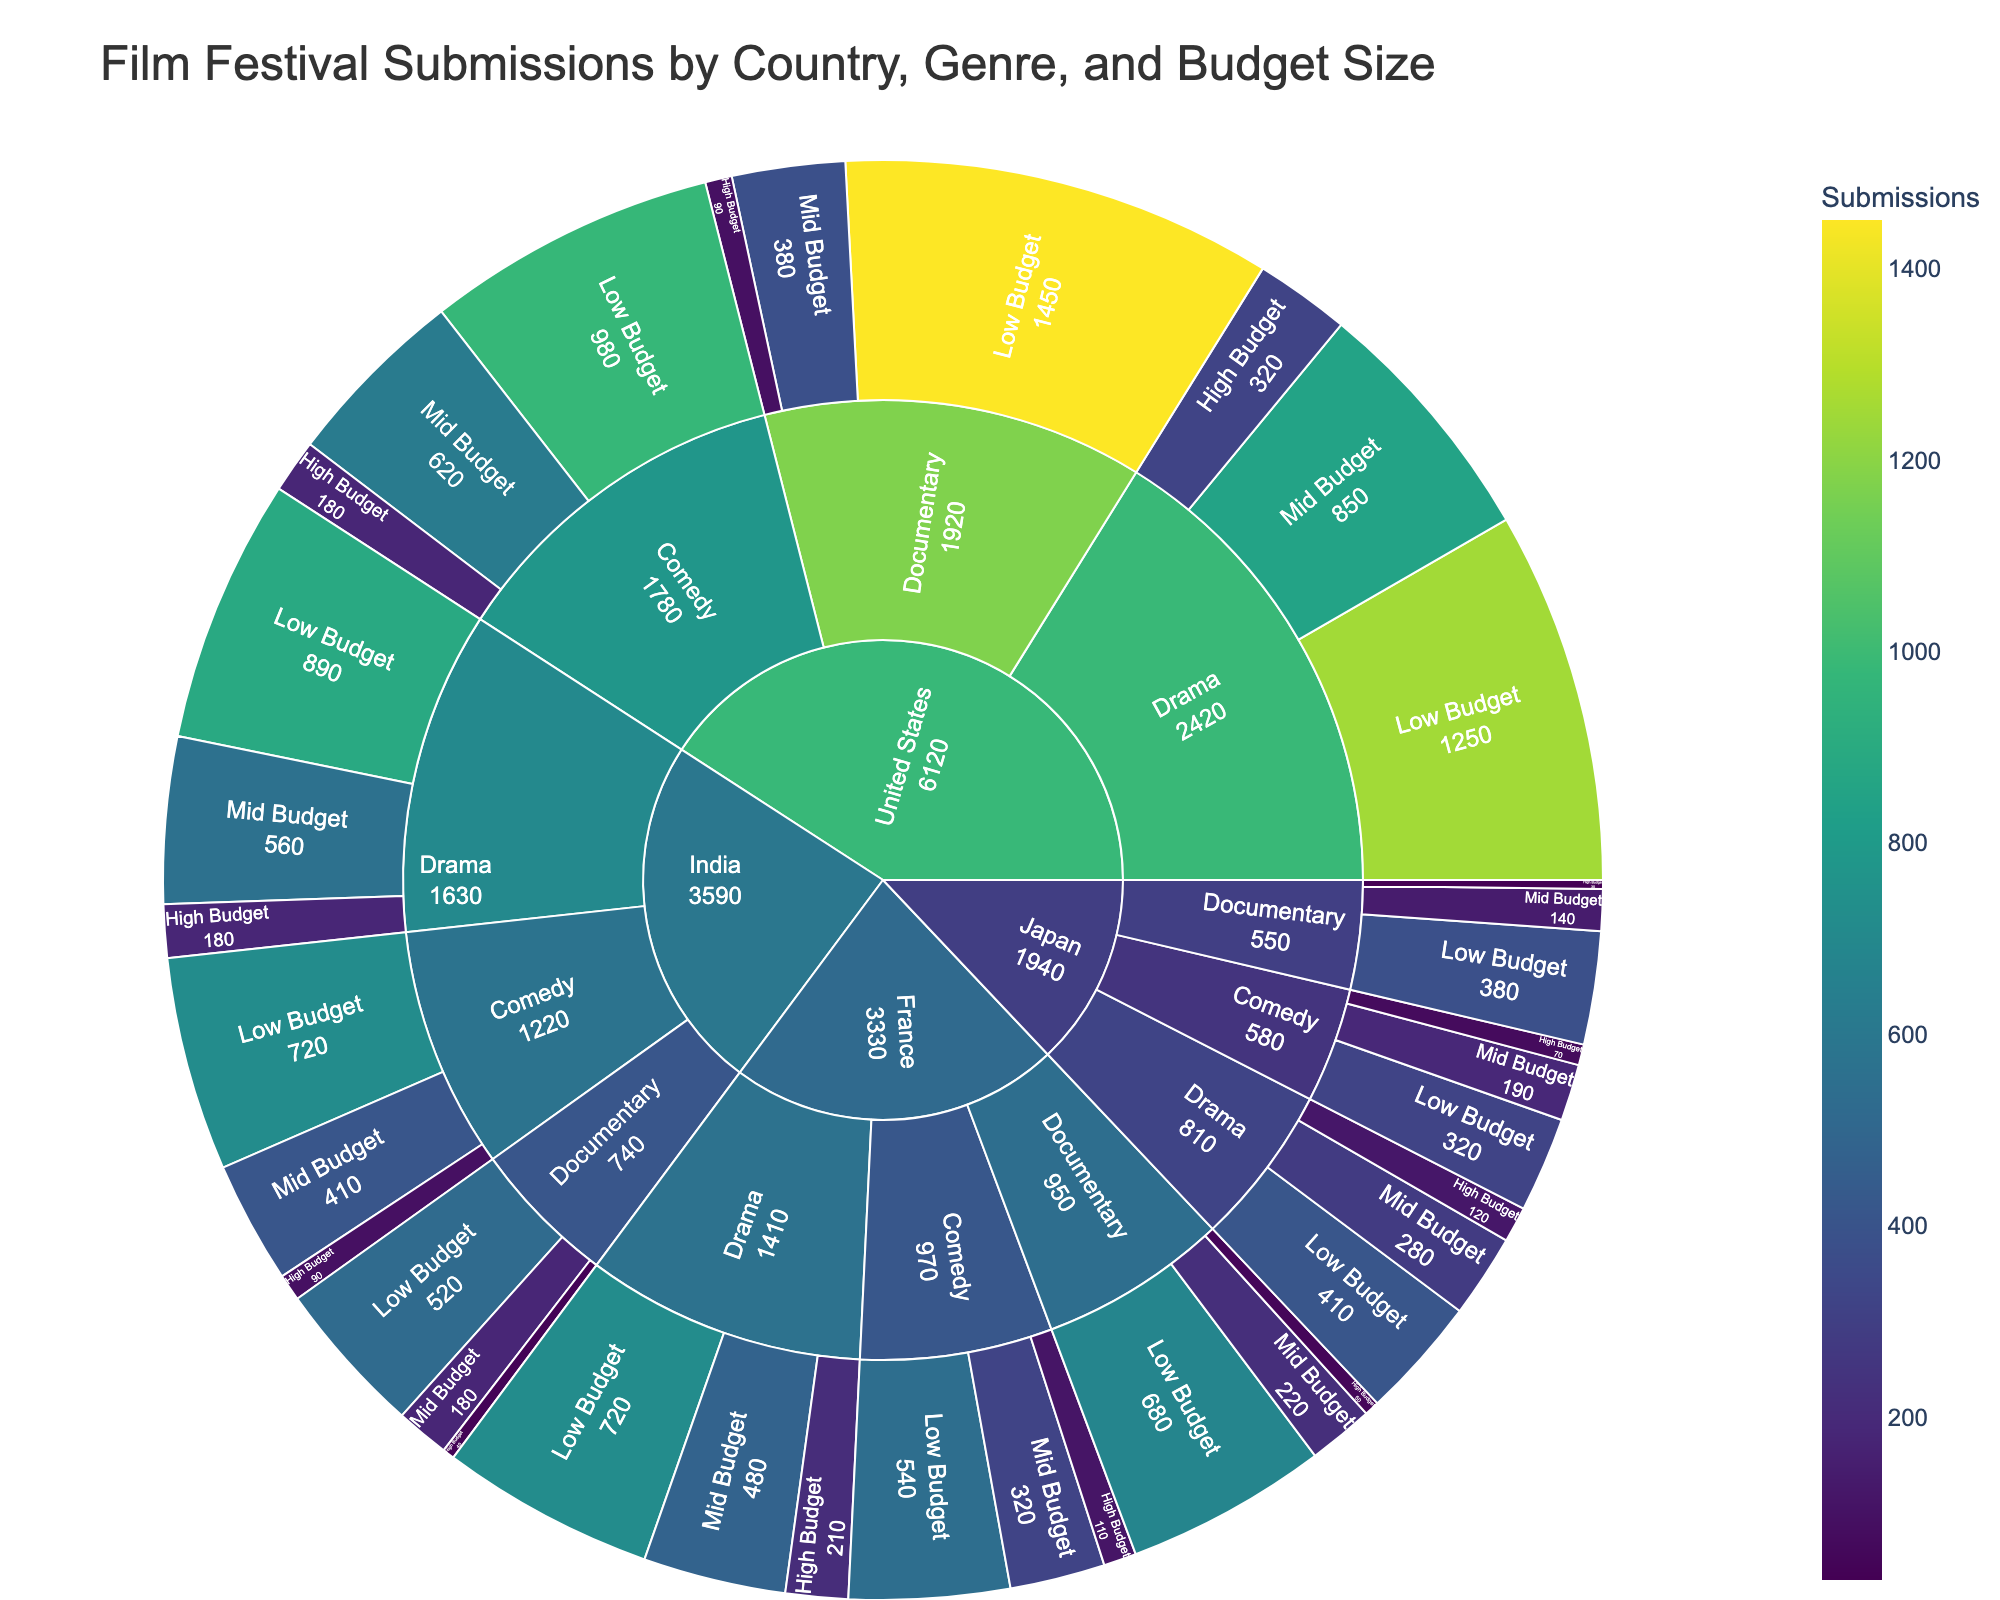What is the total number of film festival submissions from the United States? Sum the submissions for all genres and budget sizes within the United States section of the Sunburst plot: Drama (1250 + 850 + 320), Comedy (980 + 620 + 180), Documentary (1450 + 380 + 90). Calculate the total (1250 + 850 + 320 + 980 + 620 + 180 + 1450 + 380 + 90)
Answer: 6120 Which country has the highest number of low-budget documentary submissions? Identify the "Documentary" genre under "Low Budget" in each country's section and compare submission numbers: United States (1450), France (680), Japan (380), India (520). The United States has the highest
Answer: United States What genre has the least high-budget submissions in France? Look at the "High Budget" submissions under each genre in the France section: Drama (210), Comedy (110), Documentary (50). The Documentary genre has the least
Answer: Documentary Among the genres within Japan, which one has the highest mid-budget submissions? Compare the mid-budget submissions across genres within the Japan section: Drama (280), Comedy (190), Documentary (140). Drama has the highest
Answer: Drama How do the mid-budget drama submissions from India compare to those from France? Compare the mid-budget drama submissions between India and France: India (560), France (480). India's mid-budget drama submissions are higher
Answer: India's are higher Which genre in the United States has the least number of high-budget submissions? Look at the "High Budget" category under each genre in the United States section: Drama (320), Comedy (180), Documentary (90). Documentary has the least
Answer: Documentary What is the total number of submissions for all genres in Japan? Sum the submissions for all genres and budget sizes within the Japan section: Drama (410 + 280 + 120), Comedy (320 + 190 + 70), Documentary (380 + 140 + 30). Calculate the total (410 + 280 + 120 + 320 + 190 + 70 + 380 + 140 + 30)
Answer: 1940 How do comedy submissions in the United States compare to those in India across all budget sizes? Compare the total submissions for comedy in the United States (980 + 620 + 180) versus India (720 + 410 + 90): United States (1780), India (1220). Comedy submissions in the United States are higher
Answer: Comedy submissions in the US are higher What is the average number of low-budget submissions across all countries? Calculate the average of low-budget submissions from all countries: The sum (1250 + 980 + 1450 + 720 + 540 + 680 + 410 + 320 + 380 + 890 + 720 + 520) = 8860. The count of low-budget categories is 12. Divide the total by the count: 8860 / 12
Answer: 738.33 